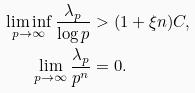Convert formula to latex. <formula><loc_0><loc_0><loc_500><loc_500>\liminf _ { p \rightarrow \infty } \frac { \lambda _ { p } } { \log p } & > ( 1 + \xi n ) C , \\ \lim _ { p \rightarrow \infty } \frac { \lambda _ { p } } { p ^ { n } } & = 0 . \\</formula> 